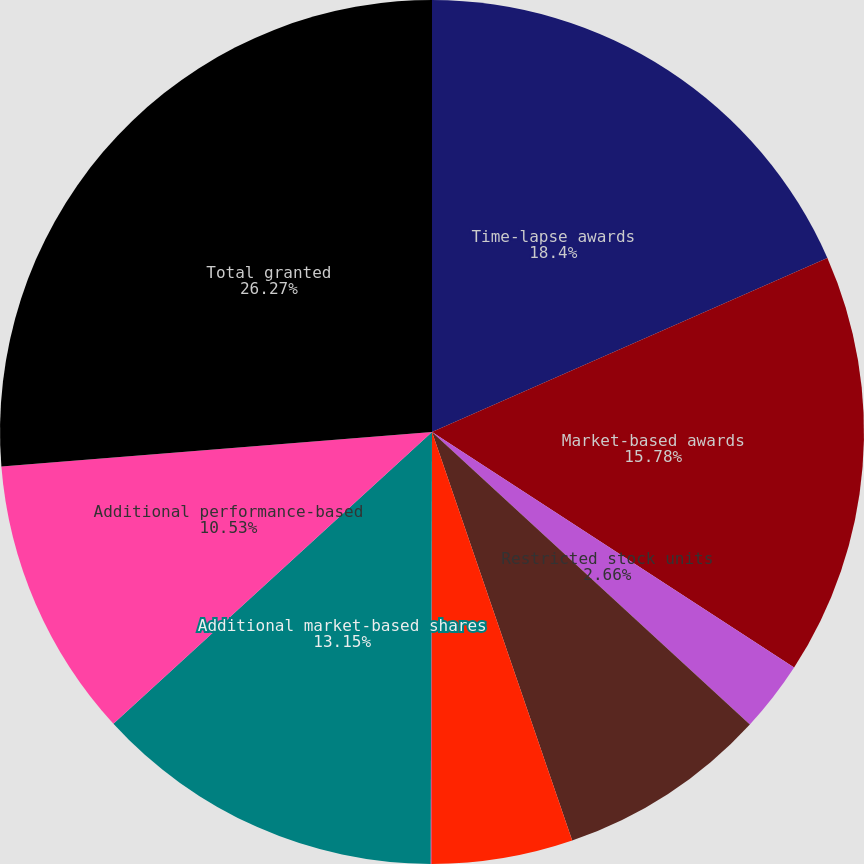<chart> <loc_0><loc_0><loc_500><loc_500><pie_chart><fcel>Time-lapse awards<fcel>Market-based awards<fcel>Restricted stock units<fcel>Dividends on market-based<fcel>Dividends on performance-based<fcel>Dividends on restricted stock<fcel>Additional market-based shares<fcel>Additional performance-based<fcel>Total granted<nl><fcel>18.4%<fcel>15.78%<fcel>2.66%<fcel>7.9%<fcel>5.28%<fcel>0.03%<fcel>13.15%<fcel>10.53%<fcel>26.27%<nl></chart> 